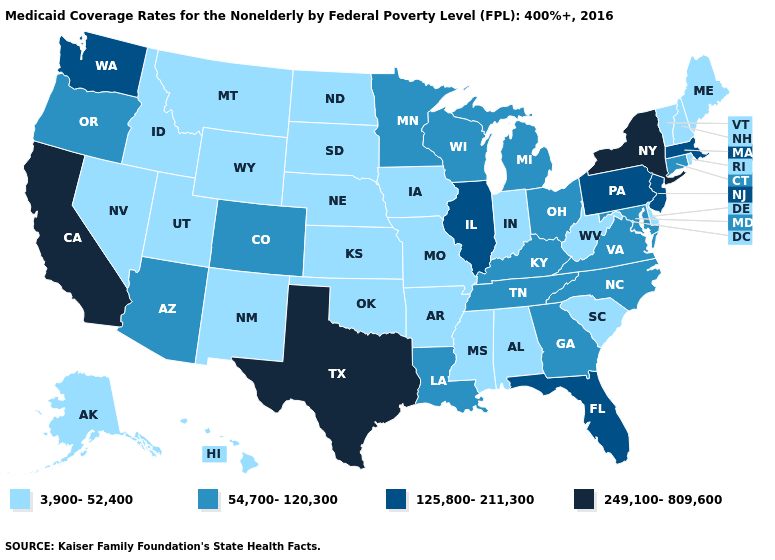Name the states that have a value in the range 249,100-809,600?
Give a very brief answer. California, New York, Texas. Name the states that have a value in the range 3,900-52,400?
Give a very brief answer. Alabama, Alaska, Arkansas, Delaware, Hawaii, Idaho, Indiana, Iowa, Kansas, Maine, Mississippi, Missouri, Montana, Nebraska, Nevada, New Hampshire, New Mexico, North Dakota, Oklahoma, Rhode Island, South Carolina, South Dakota, Utah, Vermont, West Virginia, Wyoming. Does the first symbol in the legend represent the smallest category?
Give a very brief answer. Yes. Name the states that have a value in the range 3,900-52,400?
Short answer required. Alabama, Alaska, Arkansas, Delaware, Hawaii, Idaho, Indiana, Iowa, Kansas, Maine, Mississippi, Missouri, Montana, Nebraska, Nevada, New Hampshire, New Mexico, North Dakota, Oklahoma, Rhode Island, South Carolina, South Dakota, Utah, Vermont, West Virginia, Wyoming. Among the states that border West Virginia , does Pennsylvania have the lowest value?
Concise answer only. No. Which states have the lowest value in the USA?
Short answer required. Alabama, Alaska, Arkansas, Delaware, Hawaii, Idaho, Indiana, Iowa, Kansas, Maine, Mississippi, Missouri, Montana, Nebraska, Nevada, New Hampshire, New Mexico, North Dakota, Oklahoma, Rhode Island, South Carolina, South Dakota, Utah, Vermont, West Virginia, Wyoming. What is the value of New York?
Quick response, please. 249,100-809,600. Does Massachusetts have the lowest value in the USA?
Answer briefly. No. Name the states that have a value in the range 3,900-52,400?
Concise answer only. Alabama, Alaska, Arkansas, Delaware, Hawaii, Idaho, Indiana, Iowa, Kansas, Maine, Mississippi, Missouri, Montana, Nebraska, Nevada, New Hampshire, New Mexico, North Dakota, Oklahoma, Rhode Island, South Carolina, South Dakota, Utah, Vermont, West Virginia, Wyoming. Among the states that border New Mexico , does Texas have the highest value?
Concise answer only. Yes. What is the lowest value in the South?
Be succinct. 3,900-52,400. Name the states that have a value in the range 54,700-120,300?
Quick response, please. Arizona, Colorado, Connecticut, Georgia, Kentucky, Louisiana, Maryland, Michigan, Minnesota, North Carolina, Ohio, Oregon, Tennessee, Virginia, Wisconsin. What is the lowest value in the Northeast?
Concise answer only. 3,900-52,400. Does New Hampshire have the highest value in the Northeast?
Be succinct. No. Which states have the lowest value in the USA?
Write a very short answer. Alabama, Alaska, Arkansas, Delaware, Hawaii, Idaho, Indiana, Iowa, Kansas, Maine, Mississippi, Missouri, Montana, Nebraska, Nevada, New Hampshire, New Mexico, North Dakota, Oklahoma, Rhode Island, South Carolina, South Dakota, Utah, Vermont, West Virginia, Wyoming. 